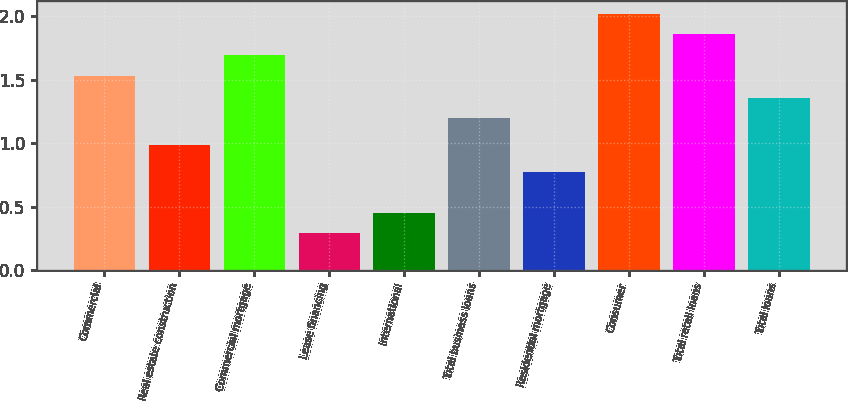Convert chart to OTSL. <chart><loc_0><loc_0><loc_500><loc_500><bar_chart><fcel>Commercial<fcel>Real estate construction<fcel>Commercial mortgage<fcel>Lease financing<fcel>International<fcel>Total business loans<fcel>Residential mortgage<fcel>Consumer<fcel>Total retail loans<fcel>Total loans<nl><fcel>1.53<fcel>0.99<fcel>1.7<fcel>0.29<fcel>0.45<fcel>1.2<fcel>0.77<fcel>2.02<fcel>1.86<fcel>1.36<nl></chart> 